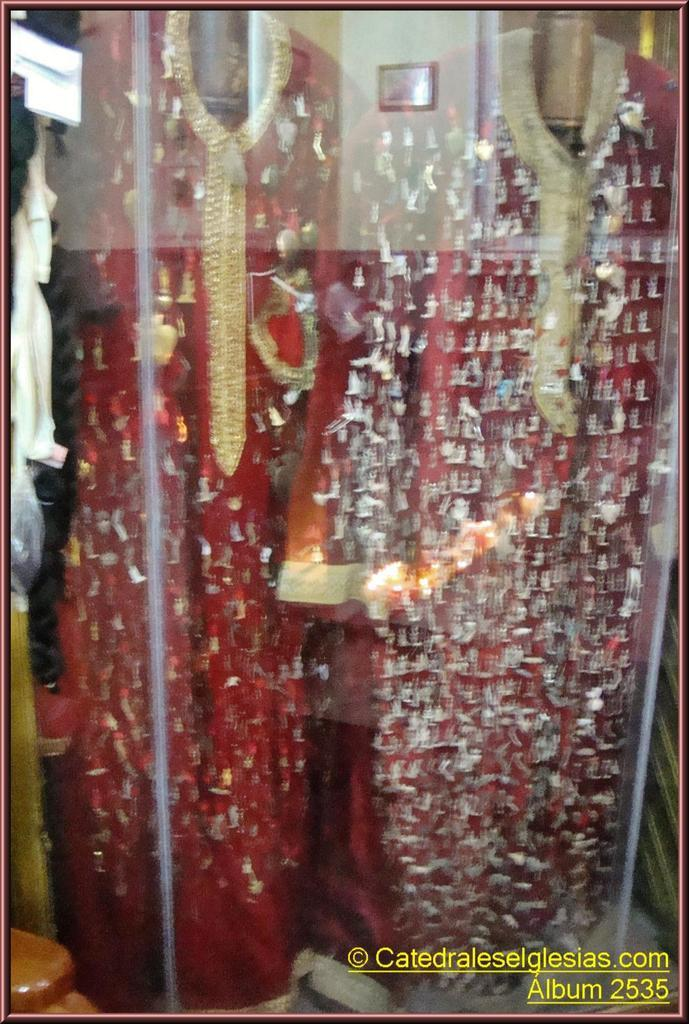What type of figures can be seen in the image? There are mannequins in the image. How are the mannequins dressed? The mannequins are dressed in the image. Where are the mannequins located? The mannequins are inside a glass display. What can be found at the bottom side of the image? There is text at the bottom side of the image. What type of clouds can be seen in the image? There are no clouds present in the image; it features mannequins inside a glass display. 